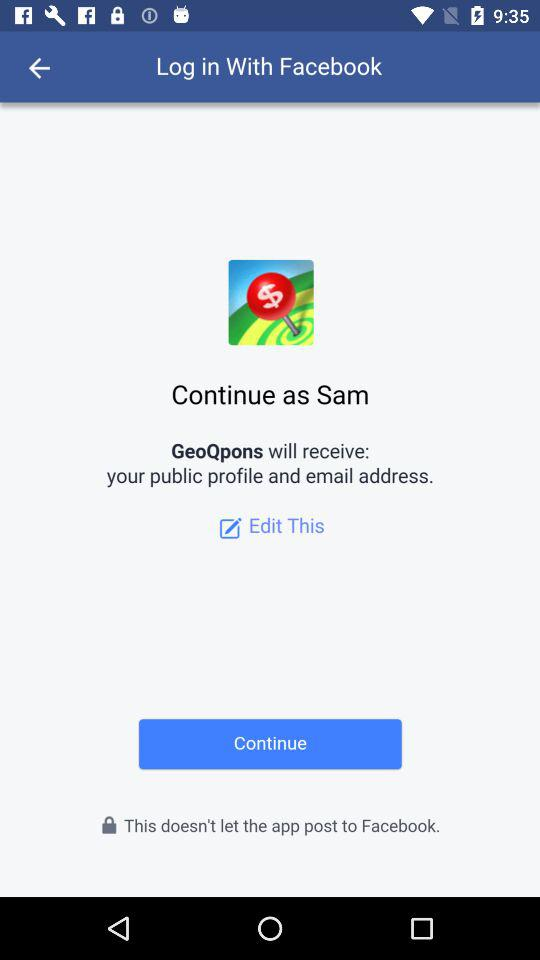What is the user name? The user name is Sam. 